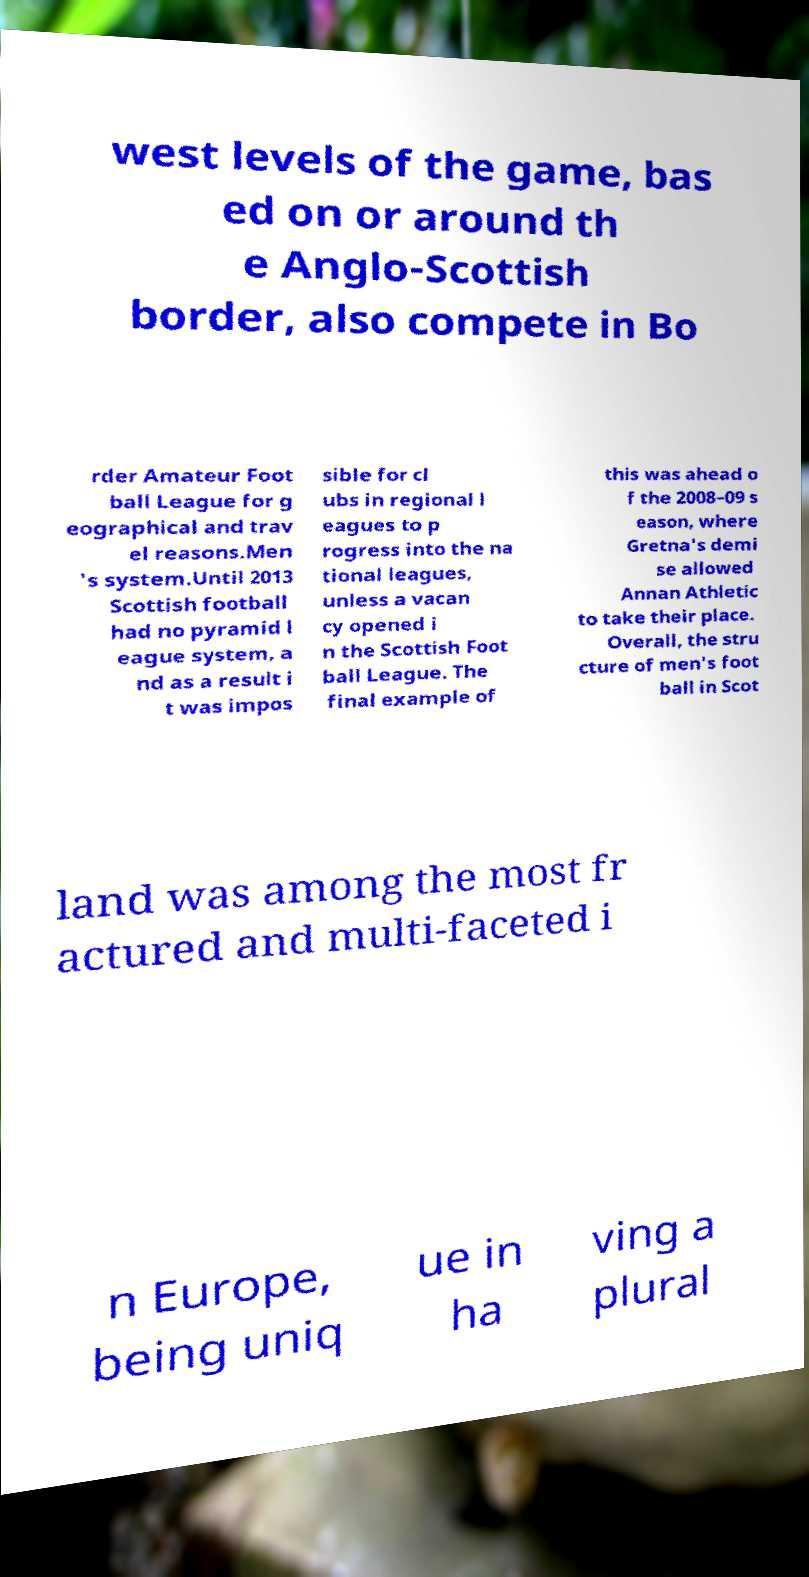There's text embedded in this image that I need extracted. Can you transcribe it verbatim? west levels of the game, bas ed on or around th e Anglo-Scottish border, also compete in Bo rder Amateur Foot ball League for g eographical and trav el reasons.Men 's system.Until 2013 Scottish football had no pyramid l eague system, a nd as a result i t was impos sible for cl ubs in regional l eagues to p rogress into the na tional leagues, unless a vacan cy opened i n the Scottish Foot ball League. The final example of this was ahead o f the 2008–09 s eason, where Gretna's demi se allowed Annan Athletic to take their place. Overall, the stru cture of men's foot ball in Scot land was among the most fr actured and multi-faceted i n Europe, being uniq ue in ha ving a plural 